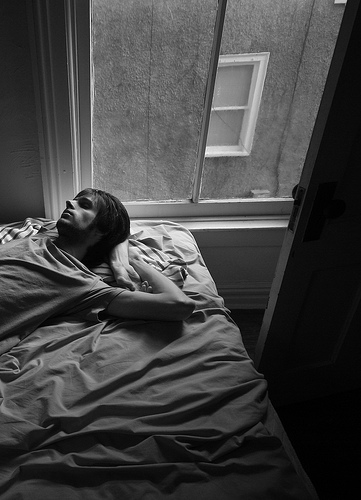Imagine if the bed was floating in the air outside the window. What would the person be seeing from there? If the bed were floating in the air outside the window, the person would have a bird's eye view of the surrounding area. They could see rooftops, streets, and perhaps even people walking by. It would be an entirely different perspective, potentially exhilarating and surreal. 